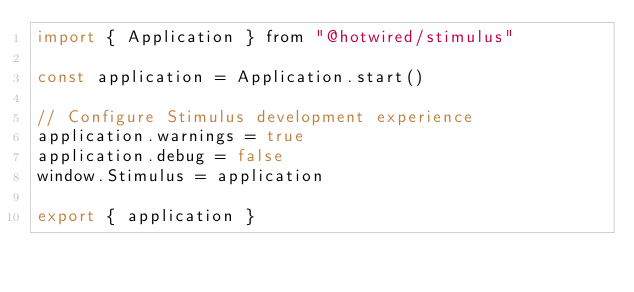<code> <loc_0><loc_0><loc_500><loc_500><_JavaScript_>import { Application } from "@hotwired/stimulus"

const application = Application.start()

// Configure Stimulus development experience
application.warnings = true
application.debug = false
window.Stimulus = application

export { application }
</code> 